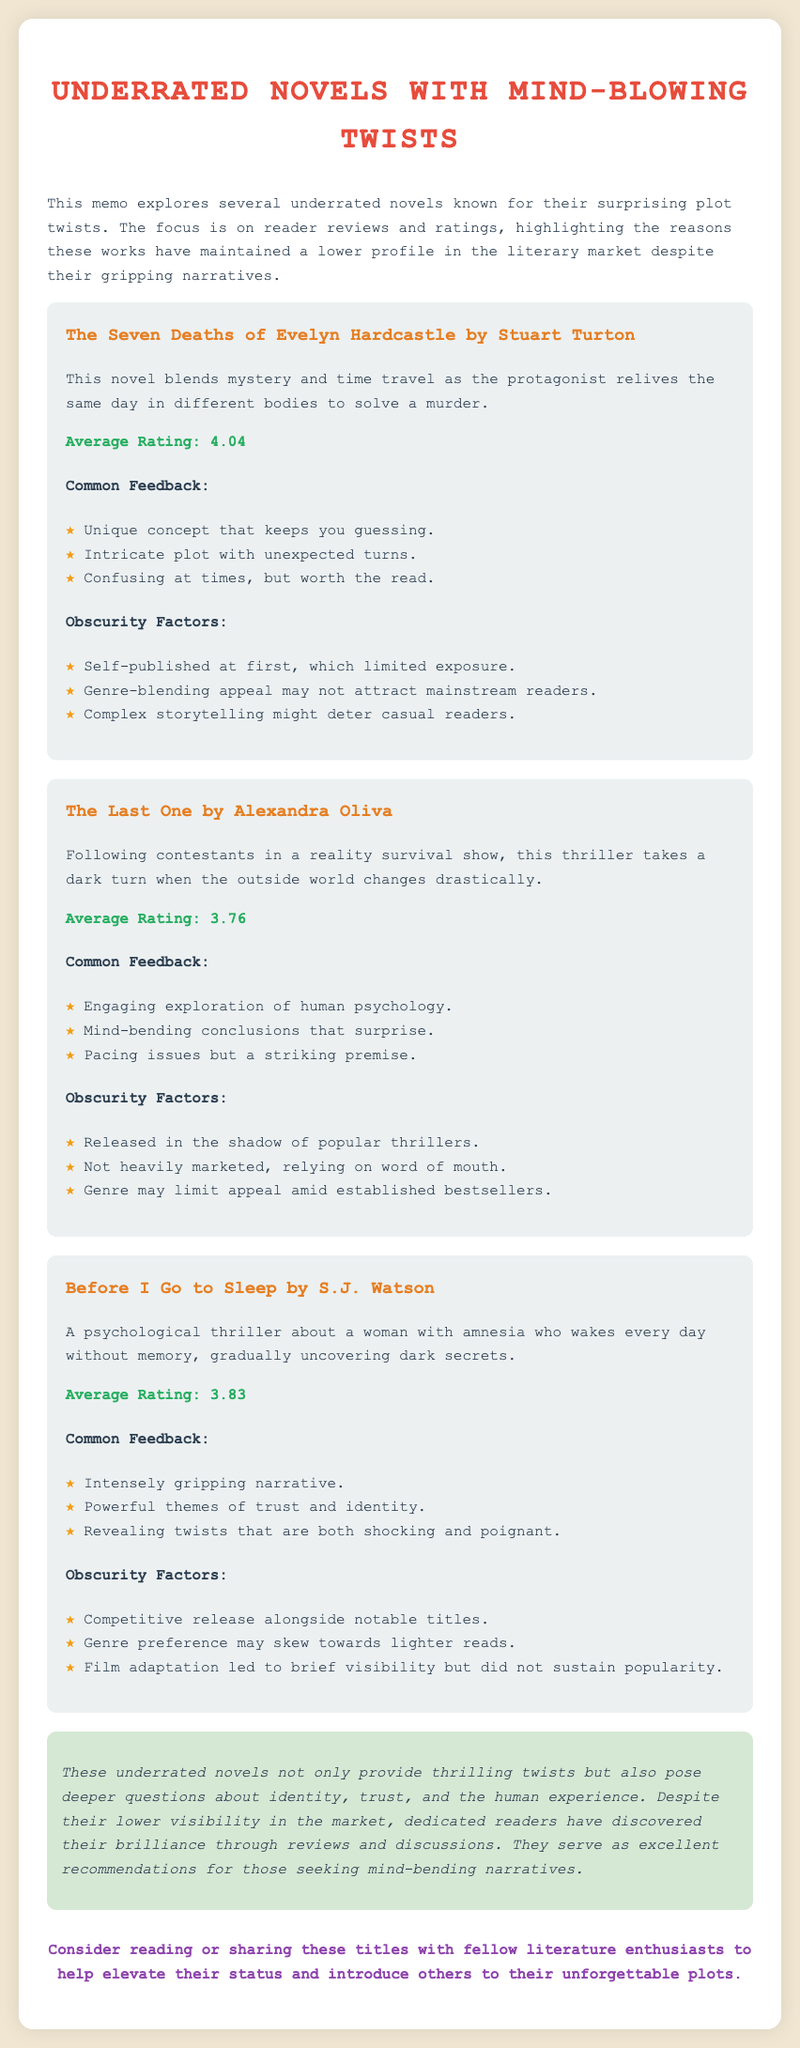What is the title of the first novel mentioned? The first novel mentioned is The Seven Deaths of Evelyn Hardcastle.
Answer: The Seven Deaths of Evelyn Hardcastle What is the average rating of The Last One? The average rating of The Last One is mentioned in the memo as 3.76.
Answer: 3.76 Which novel involves a protagonist with amnesia? The novel that involves a protagonist with amnesia is Before I Go to Sleep.
Answer: Before I Go to Sleep What is a common feedback point for The Seven Deaths of Evelyn Hardcastle? A common feedback point for The Seven Deaths of Evelyn Hardcastle is that it has a unique concept that keeps you guessing.
Answer: Unique concept that keeps you guessing Why did The Last One maintain a lower profile? The Last One maintained a lower profile due to being released in the shadow of popular thrillers.
Answer: Released in the shadow of popular thrillers How does the document describe the overall theme of the novels? The overall theme of the novels is described as posing deeper questions about identity, trust, and the human experience.
Answer: Identity, trust, and the human experience What color is the background of the memo? The background color of the memo is light beige (#f0e6d2).
Answer: light beige What kind of genres do these novels blend? These novels blend genres such as mystery, psychological thriller, and reality survival.
Answer: Mystery, psychological thriller, and reality survival 